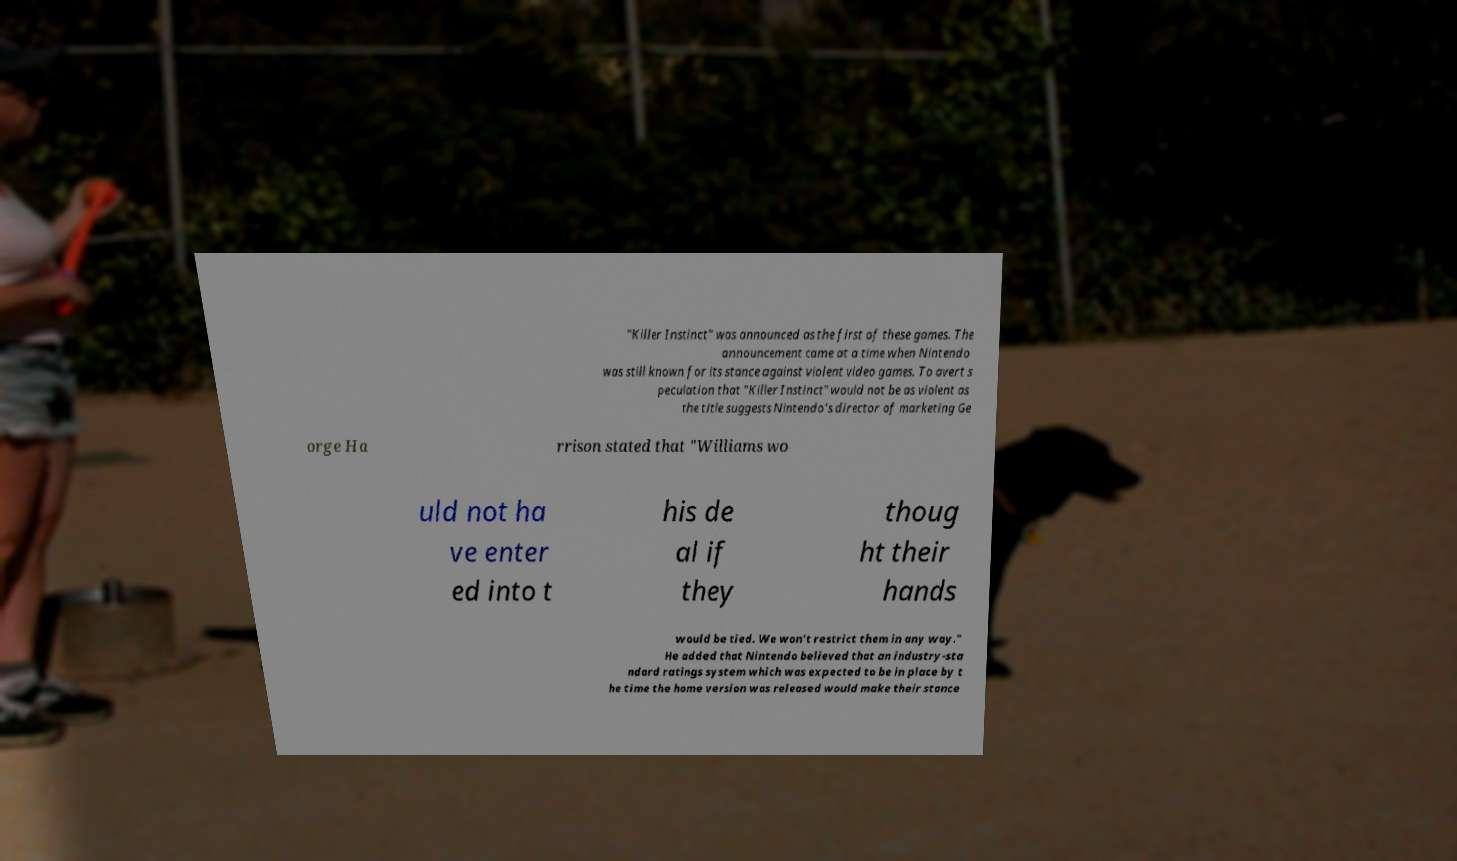Please read and relay the text visible in this image. What does it say? "Killer Instinct" was announced as the first of these games. The announcement came at a time when Nintendo was still known for its stance against violent video games. To avert s peculation that "Killer Instinct" would not be as violent as the title suggests Nintendo's director of marketing Ge orge Ha rrison stated that "Williams wo uld not ha ve enter ed into t his de al if they thoug ht their hands would be tied. We won't restrict them in any way." He added that Nintendo believed that an industry-sta ndard ratings system which was expected to be in place by t he time the home version was released would make their stance 